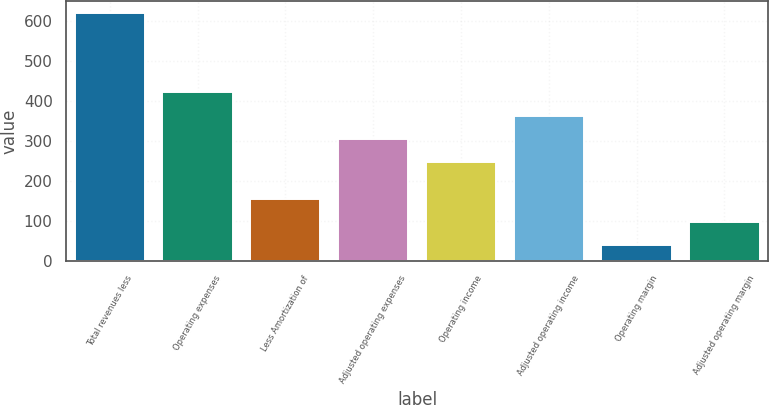Convert chart. <chart><loc_0><loc_0><loc_500><loc_500><bar_chart><fcel>Total revenues less<fcel>Operating expenses<fcel>Less Amortization of<fcel>Adjusted operating expenses<fcel>Operating income<fcel>Adjusted operating income<fcel>Operating margin<fcel>Adjusted operating margin<nl><fcel>620<fcel>422<fcel>156<fcel>306<fcel>248<fcel>364<fcel>40<fcel>98<nl></chart> 